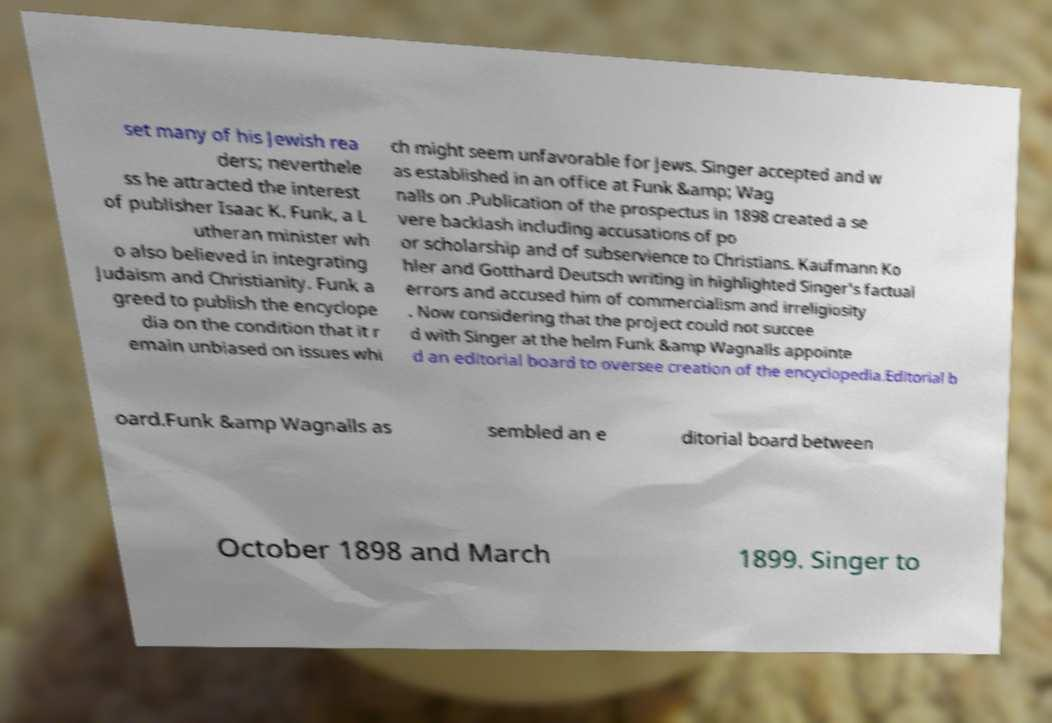I need the written content from this picture converted into text. Can you do that? set many of his Jewish rea ders; neverthele ss he attracted the interest of publisher Isaac K. Funk, a L utheran minister wh o also believed in integrating Judaism and Christianity. Funk a greed to publish the encyclope dia on the condition that it r emain unbiased on issues whi ch might seem unfavorable for Jews. Singer accepted and w as established in an office at Funk &amp; Wag nalls on .Publication of the prospectus in 1898 created a se vere backlash including accusations of po or scholarship and of subservience to Christians. Kaufmann Ko hler and Gotthard Deutsch writing in highlighted Singer's factual errors and accused him of commercialism and irreligiosity . Now considering that the project could not succee d with Singer at the helm Funk &amp Wagnalls appointe d an editorial board to oversee creation of the encyclopedia.Editorial b oard.Funk &amp Wagnalls as sembled an e ditorial board between October 1898 and March 1899. Singer to 